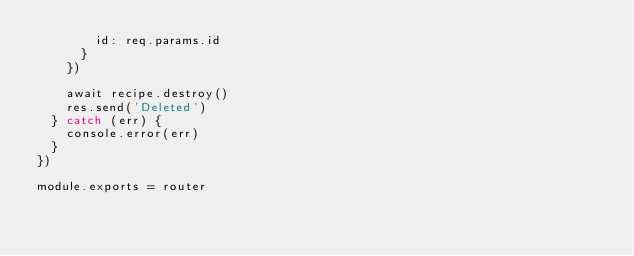Convert code to text. <code><loc_0><loc_0><loc_500><loc_500><_JavaScript_>        id: req.params.id
      }
    })

    await recipe.destroy()
    res.send('Deleted')
  } catch (err) {
    console.error(err)
  }
})

module.exports = router
</code> 